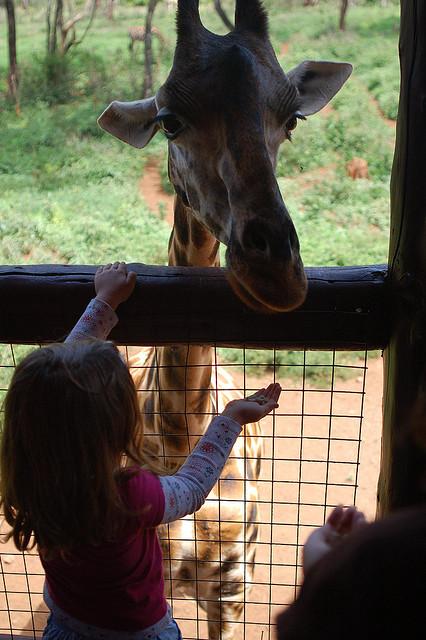What is the little girl feeding?
Write a very short answer. Giraffe. Where is the little kid?
Short answer required. Zoo. What animal is this?
Give a very brief answer. Giraffe. 